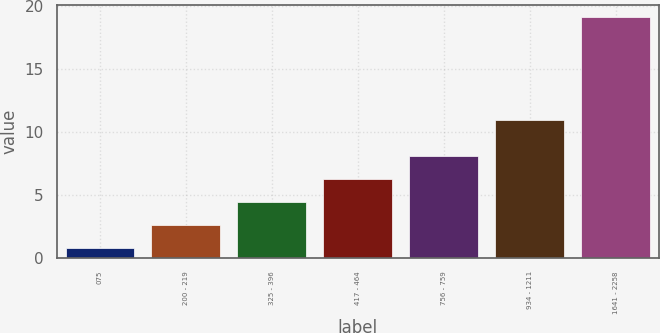Convert chart. <chart><loc_0><loc_0><loc_500><loc_500><bar_chart><fcel>075<fcel>200 - 219<fcel>325 - 396<fcel>417 - 464<fcel>756 - 759<fcel>934 - 1211<fcel>1641 - 2258<nl><fcel>0.75<fcel>2.59<fcel>4.43<fcel>6.27<fcel>8.11<fcel>10.96<fcel>19.12<nl></chart> 